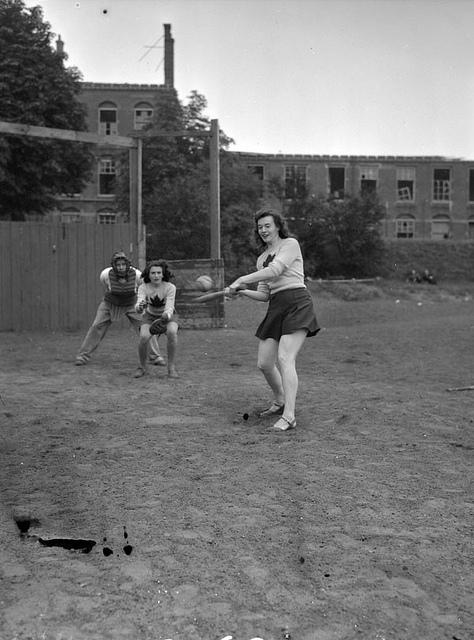How many shrubs are in this picture?
Write a very short answer. 3. What sport is this?
Keep it brief. Softball. Is there a tree?
Short answer required. Yes. Is this a modern picture?
Be succinct. No. 